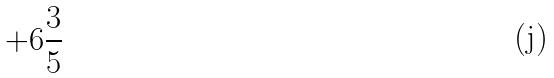Convert formula to latex. <formula><loc_0><loc_0><loc_500><loc_500>+ 6 \frac { 3 } { 5 }</formula> 